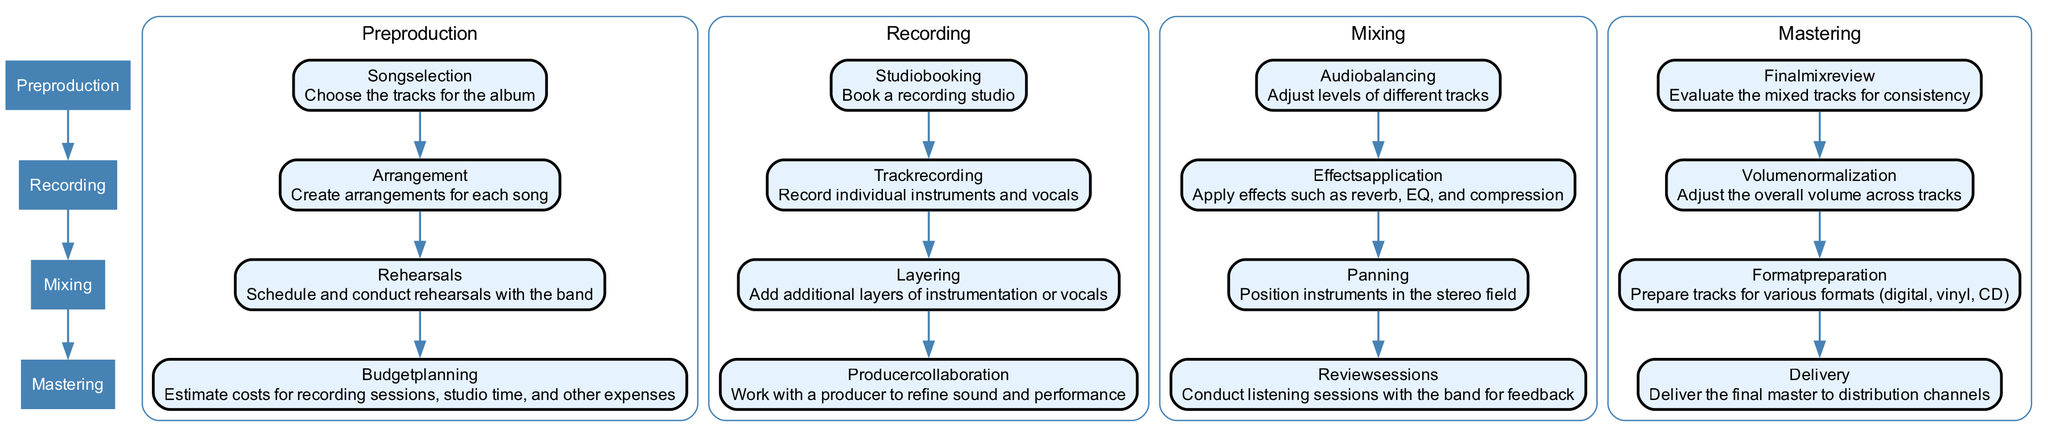What are the four main phases of the album recording workflow? The diagram outlines four main phases: Pre-Production, Recording, Mixing, and Mastering. Each phase is represented as a primary node that organizes the entire workflow.
Answer: Pre-Production, Recording, Mixing, Mastering Which step comes after "Track Recording" in the workflow? The diagram illustrates a sequence of steps within each phase. After "Track Recording," the next step is "Layering," which adds more layers of instrumentation or vocals.
Answer: Layering How many substeps are included in the Mixing phase? The Mixing phase contains four substeps: Audio Balancing, Effects Application, Panning, and Review Sessions. This can be counted directly from the sub-nodes listed under the Mixing phase.
Answer: Four What is the purpose of the "Producer Collaboration" step? The "Producer Collaboration" step focuses on working with a producer to refine the sound and performance during the recording phase. This can be deduced from its description in the diagram.
Answer: Refine sound and performance Which workflow phase requires scheduling and conducting rehearsals? The "Rehearsals" step is part of the Pre-Production phase, where rehearsals are scheduled and conducted with the band to prepare for recording. This information is found directly in the Pre-Production section.
Answer: Pre-Production What is the first step listed under the Mastering phase? The first step under the Mastering phase is "Final Mix Review," focusing on evaluating mixed tracks for consistency before further processing. This follows the sequence established in the diagram.
Answer: Final Mix Review How many total steps are there in the Recording phase? The Recording phase consists of four distinct steps: Studio Booking, Track Recording, Layering, and Producer Collaboration. The number of steps can be counted from the sub-nodes listed under the Recording phase.
Answer: Four What step involves preparing tracks for various formats? The step "Format Preparation" is specifically dedicated to preparing the tracks for various formats like digital, vinyl, and CD in the Mastering phase. This is clearly described in that section of the diagram.
Answer: Format Preparation Which two phases directly connect the "Budget Planning" step? The "Budget Planning" step is a part of the Pre-Production phase and is connected to the Recording phase, making it directly linked with the workflow continuity. This can be visualized through the edges connecting the phases.
Answer: Pre-Production and Recording 